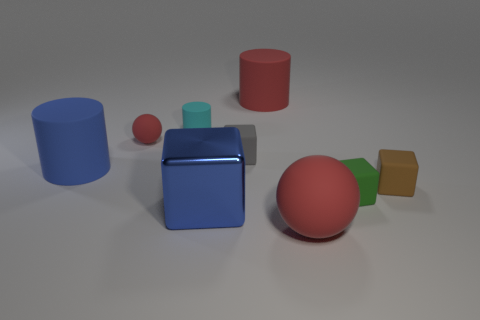There is a sphere that is behind the big rubber object that is on the right side of the big rubber object that is behind the small cylinder; what is its size?
Give a very brief answer. Small. How many big red objects are the same material as the tiny red ball?
Keep it short and to the point. 2. Are there fewer brown objects than red rubber balls?
Your answer should be very brief. Yes. What is the size of the blue thing that is the same shape as the tiny cyan matte object?
Your response must be concise. Large. Are the red sphere to the right of the tiny cyan object and the tiny green block made of the same material?
Provide a short and direct response. Yes. Does the tiny gray thing have the same shape as the small brown thing?
Keep it short and to the point. Yes. What number of things are either tiny blocks that are on the right side of the red matte cylinder or tiny green matte blocks?
Offer a very short reply. 2. There is a brown thing that is the same material as the green cube; what size is it?
Give a very brief answer. Small. How many large matte objects have the same color as the large metal cube?
Make the answer very short. 1. How many small objects are green metallic spheres or blue matte things?
Provide a short and direct response. 0. 